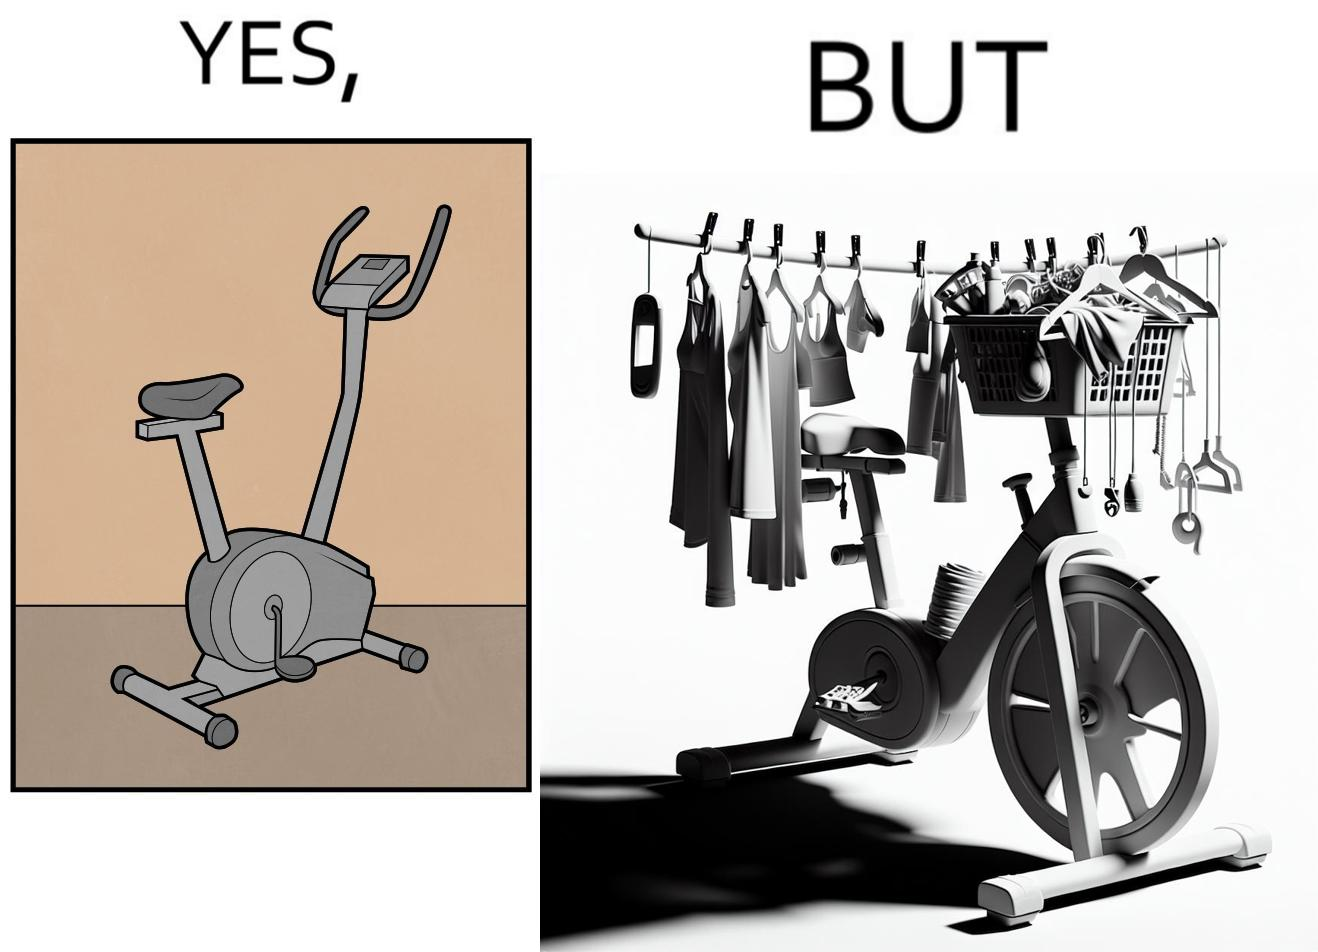Is there satirical content in this image? Yes, this image is satirical. 